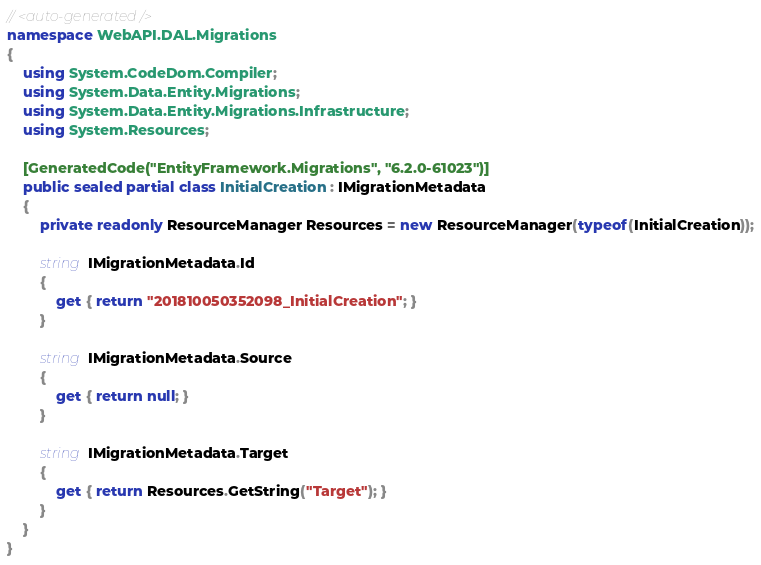<code> <loc_0><loc_0><loc_500><loc_500><_C#_>// <auto-generated />
namespace WebAPI.DAL.Migrations
{
    using System.CodeDom.Compiler;
    using System.Data.Entity.Migrations;
    using System.Data.Entity.Migrations.Infrastructure;
    using System.Resources;
    
    [GeneratedCode("EntityFramework.Migrations", "6.2.0-61023")]
    public sealed partial class InitialCreation : IMigrationMetadata
    {
        private readonly ResourceManager Resources = new ResourceManager(typeof(InitialCreation));
        
        string IMigrationMetadata.Id
        {
            get { return "201810050352098_InitialCreation"; }
        }
        
        string IMigrationMetadata.Source
        {
            get { return null; }
        }
        
        string IMigrationMetadata.Target
        {
            get { return Resources.GetString("Target"); }
        }
    }
}
</code> 